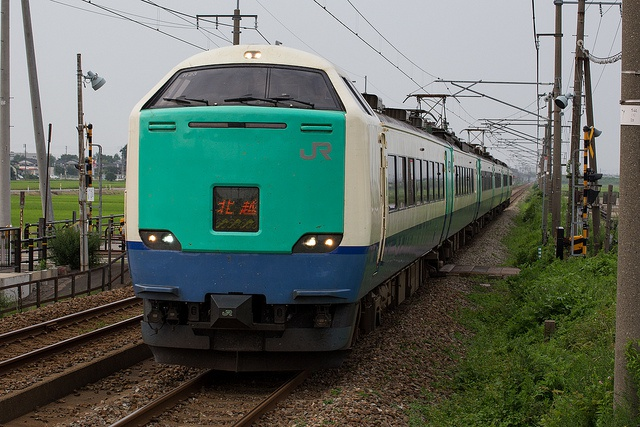Describe the objects in this image and their specific colors. I can see train in lightgray, black, teal, and gray tones, traffic light in lightgray, black, gray, and maroon tones, traffic light in lightgray, black, maroon, gray, and darkblue tones, and traffic light in lightgray, black, and gray tones in this image. 